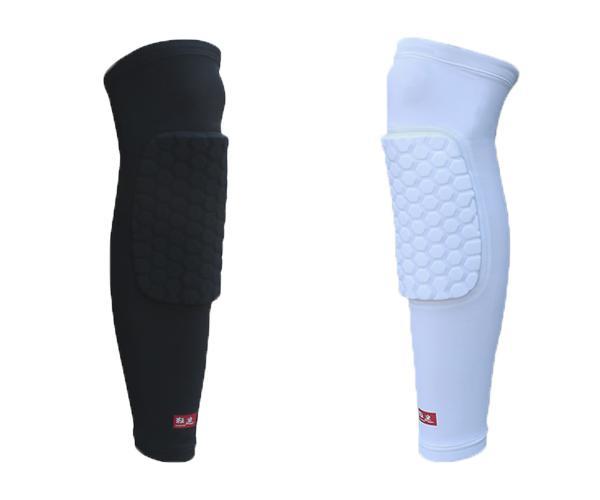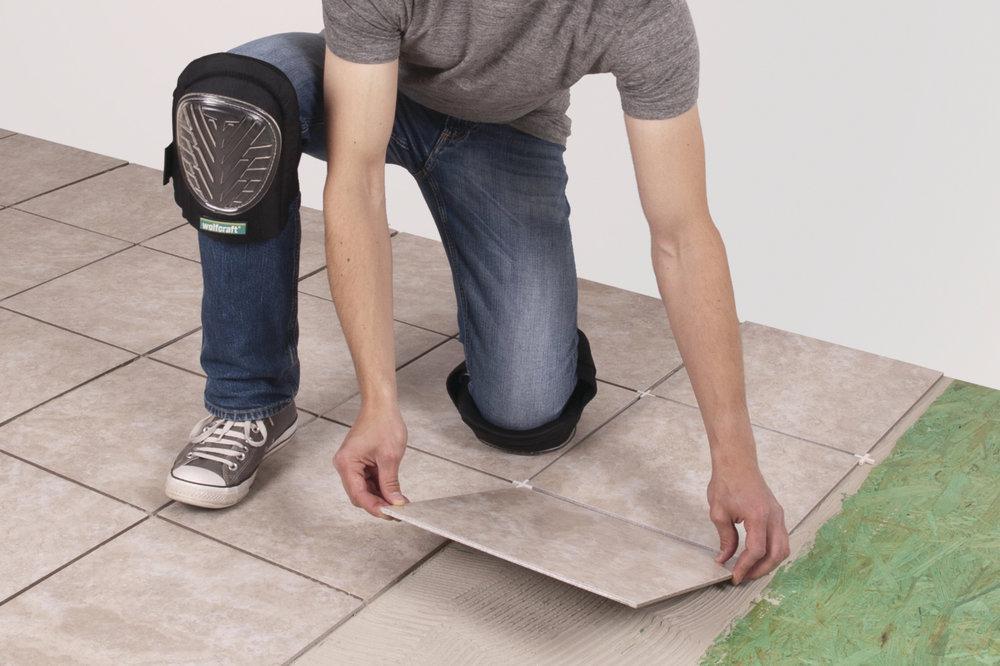The first image is the image on the left, the second image is the image on the right. Given the left and right images, does the statement "All images featuring kneepads include human legs." hold true? Answer yes or no. No. The first image is the image on the left, the second image is the image on the right. Assess this claim about the two images: "one of the male legs has a brace, the other is bare". Correct or not? Answer yes or no. No. 